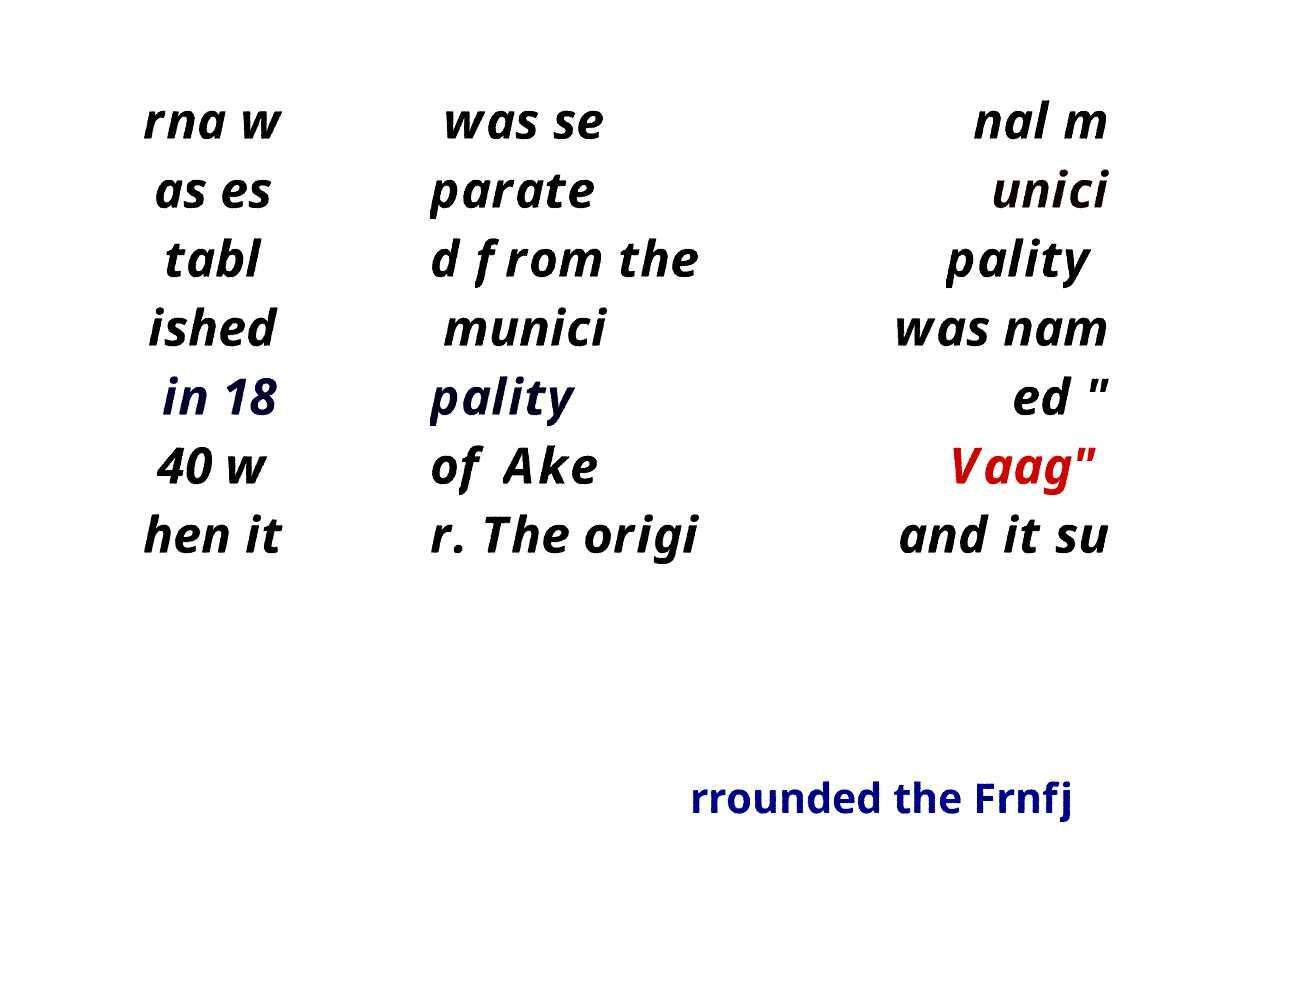There's text embedded in this image that I need extracted. Can you transcribe it verbatim? rna w as es tabl ished in 18 40 w hen it was se parate d from the munici pality of Ake r. The origi nal m unici pality was nam ed " Vaag" and it su rrounded the Frnfj 